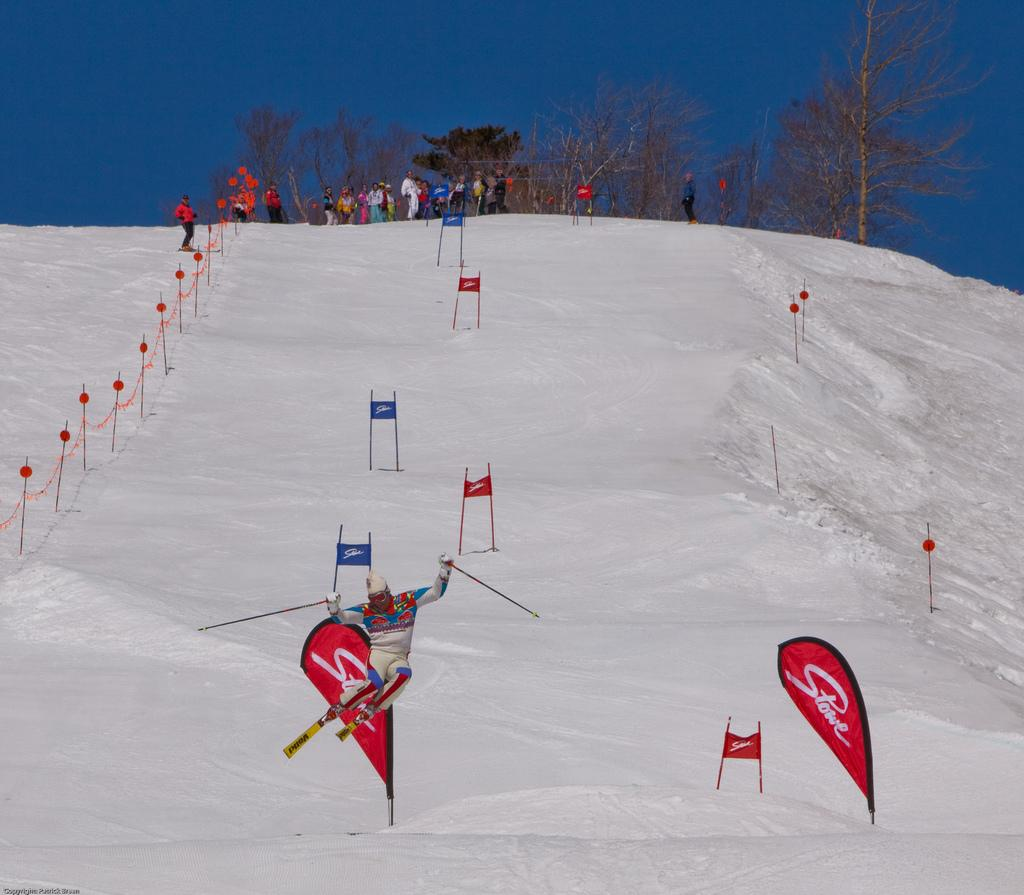<image>
Provide a brief description of the given image. skiers at the top of the hill while another passes through the stone banner signs at the bottom 